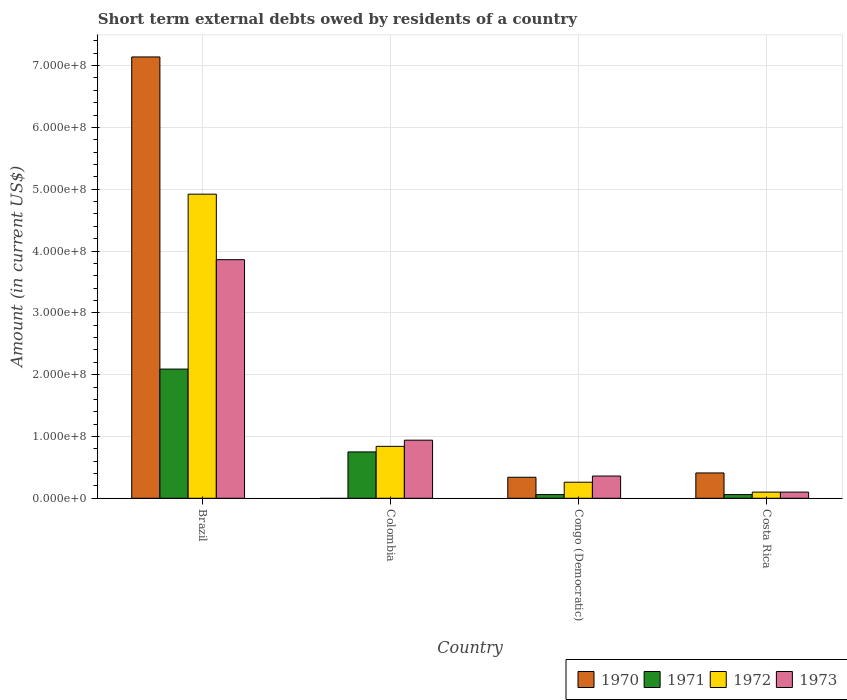Are the number of bars per tick equal to the number of legend labels?
Give a very brief answer. No. How many bars are there on the 1st tick from the right?
Your response must be concise. 4. What is the label of the 4th group of bars from the left?
Give a very brief answer. Costa Rica. In how many cases, is the number of bars for a given country not equal to the number of legend labels?
Keep it short and to the point. 1. What is the amount of short-term external debts owed by residents in 1970 in Brazil?
Make the answer very short. 7.14e+08. Across all countries, what is the maximum amount of short-term external debts owed by residents in 1973?
Offer a terse response. 3.86e+08. What is the total amount of short-term external debts owed by residents in 1973 in the graph?
Provide a short and direct response. 5.26e+08. What is the difference between the amount of short-term external debts owed by residents in 1972 in Brazil and that in Costa Rica?
Keep it short and to the point. 4.82e+08. What is the difference between the amount of short-term external debts owed by residents in 1972 in Colombia and the amount of short-term external debts owed by residents in 1971 in Costa Rica?
Your answer should be very brief. 7.80e+07. What is the average amount of short-term external debts owed by residents in 1971 per country?
Your response must be concise. 7.40e+07. What is the difference between the amount of short-term external debts owed by residents of/in 1971 and amount of short-term external debts owed by residents of/in 1970 in Congo (Democratic)?
Give a very brief answer. -2.80e+07. What is the ratio of the amount of short-term external debts owed by residents in 1973 in Colombia to that in Costa Rica?
Offer a terse response. 9.4. Is the amount of short-term external debts owed by residents in 1972 in Brazil less than that in Congo (Democratic)?
Your answer should be very brief. No. What is the difference between the highest and the second highest amount of short-term external debts owed by residents in 1973?
Your answer should be compact. 3.50e+08. What is the difference between the highest and the lowest amount of short-term external debts owed by residents in 1970?
Keep it short and to the point. 7.14e+08. In how many countries, is the amount of short-term external debts owed by residents in 1972 greater than the average amount of short-term external debts owed by residents in 1972 taken over all countries?
Ensure brevity in your answer.  1. Is it the case that in every country, the sum of the amount of short-term external debts owed by residents in 1972 and amount of short-term external debts owed by residents in 1971 is greater than the amount of short-term external debts owed by residents in 1970?
Make the answer very short. No. What is the difference between two consecutive major ticks on the Y-axis?
Your answer should be compact. 1.00e+08. How many legend labels are there?
Your answer should be very brief. 4. What is the title of the graph?
Ensure brevity in your answer.  Short term external debts owed by residents of a country. Does "1986" appear as one of the legend labels in the graph?
Your answer should be very brief. No. What is the label or title of the X-axis?
Offer a very short reply. Country. What is the label or title of the Y-axis?
Your answer should be compact. Amount (in current US$). What is the Amount (in current US$) of 1970 in Brazil?
Offer a very short reply. 7.14e+08. What is the Amount (in current US$) in 1971 in Brazil?
Make the answer very short. 2.09e+08. What is the Amount (in current US$) of 1972 in Brazil?
Make the answer very short. 4.92e+08. What is the Amount (in current US$) in 1973 in Brazil?
Offer a terse response. 3.86e+08. What is the Amount (in current US$) of 1970 in Colombia?
Provide a short and direct response. 0. What is the Amount (in current US$) in 1971 in Colombia?
Make the answer very short. 7.50e+07. What is the Amount (in current US$) of 1972 in Colombia?
Give a very brief answer. 8.40e+07. What is the Amount (in current US$) in 1973 in Colombia?
Ensure brevity in your answer.  9.40e+07. What is the Amount (in current US$) of 1970 in Congo (Democratic)?
Provide a succinct answer. 3.40e+07. What is the Amount (in current US$) in 1971 in Congo (Democratic)?
Your response must be concise. 6.00e+06. What is the Amount (in current US$) in 1972 in Congo (Democratic)?
Make the answer very short. 2.60e+07. What is the Amount (in current US$) of 1973 in Congo (Democratic)?
Offer a very short reply. 3.60e+07. What is the Amount (in current US$) of 1970 in Costa Rica?
Provide a succinct answer. 4.10e+07. Across all countries, what is the maximum Amount (in current US$) of 1970?
Your answer should be very brief. 7.14e+08. Across all countries, what is the maximum Amount (in current US$) of 1971?
Offer a very short reply. 2.09e+08. Across all countries, what is the maximum Amount (in current US$) in 1972?
Your answer should be very brief. 4.92e+08. Across all countries, what is the maximum Amount (in current US$) in 1973?
Your answer should be compact. 3.86e+08. Across all countries, what is the minimum Amount (in current US$) in 1970?
Offer a very short reply. 0. Across all countries, what is the minimum Amount (in current US$) of 1972?
Provide a succinct answer. 1.00e+07. Across all countries, what is the minimum Amount (in current US$) in 1973?
Your answer should be compact. 1.00e+07. What is the total Amount (in current US$) in 1970 in the graph?
Provide a short and direct response. 7.89e+08. What is the total Amount (in current US$) of 1971 in the graph?
Make the answer very short. 2.96e+08. What is the total Amount (in current US$) in 1972 in the graph?
Make the answer very short. 6.12e+08. What is the total Amount (in current US$) in 1973 in the graph?
Your answer should be compact. 5.26e+08. What is the difference between the Amount (in current US$) in 1971 in Brazil and that in Colombia?
Ensure brevity in your answer.  1.34e+08. What is the difference between the Amount (in current US$) of 1972 in Brazil and that in Colombia?
Ensure brevity in your answer.  4.08e+08. What is the difference between the Amount (in current US$) of 1973 in Brazil and that in Colombia?
Your response must be concise. 2.92e+08. What is the difference between the Amount (in current US$) in 1970 in Brazil and that in Congo (Democratic)?
Make the answer very short. 6.80e+08. What is the difference between the Amount (in current US$) in 1971 in Brazil and that in Congo (Democratic)?
Give a very brief answer. 2.03e+08. What is the difference between the Amount (in current US$) of 1972 in Brazil and that in Congo (Democratic)?
Keep it short and to the point. 4.66e+08. What is the difference between the Amount (in current US$) of 1973 in Brazil and that in Congo (Democratic)?
Provide a succinct answer. 3.50e+08. What is the difference between the Amount (in current US$) of 1970 in Brazil and that in Costa Rica?
Keep it short and to the point. 6.73e+08. What is the difference between the Amount (in current US$) in 1971 in Brazil and that in Costa Rica?
Your response must be concise. 2.03e+08. What is the difference between the Amount (in current US$) of 1972 in Brazil and that in Costa Rica?
Keep it short and to the point. 4.82e+08. What is the difference between the Amount (in current US$) of 1973 in Brazil and that in Costa Rica?
Your answer should be very brief. 3.76e+08. What is the difference between the Amount (in current US$) in 1971 in Colombia and that in Congo (Democratic)?
Make the answer very short. 6.90e+07. What is the difference between the Amount (in current US$) of 1972 in Colombia and that in Congo (Democratic)?
Ensure brevity in your answer.  5.80e+07. What is the difference between the Amount (in current US$) in 1973 in Colombia and that in Congo (Democratic)?
Keep it short and to the point. 5.80e+07. What is the difference between the Amount (in current US$) of 1971 in Colombia and that in Costa Rica?
Provide a short and direct response. 6.90e+07. What is the difference between the Amount (in current US$) of 1972 in Colombia and that in Costa Rica?
Ensure brevity in your answer.  7.40e+07. What is the difference between the Amount (in current US$) in 1973 in Colombia and that in Costa Rica?
Keep it short and to the point. 8.40e+07. What is the difference between the Amount (in current US$) in 1970 in Congo (Democratic) and that in Costa Rica?
Your answer should be very brief. -7.00e+06. What is the difference between the Amount (in current US$) in 1971 in Congo (Democratic) and that in Costa Rica?
Your answer should be very brief. 0. What is the difference between the Amount (in current US$) of 1972 in Congo (Democratic) and that in Costa Rica?
Provide a succinct answer. 1.60e+07. What is the difference between the Amount (in current US$) of 1973 in Congo (Democratic) and that in Costa Rica?
Your answer should be very brief. 2.60e+07. What is the difference between the Amount (in current US$) in 1970 in Brazil and the Amount (in current US$) in 1971 in Colombia?
Your response must be concise. 6.39e+08. What is the difference between the Amount (in current US$) of 1970 in Brazil and the Amount (in current US$) of 1972 in Colombia?
Your answer should be compact. 6.30e+08. What is the difference between the Amount (in current US$) of 1970 in Brazil and the Amount (in current US$) of 1973 in Colombia?
Provide a succinct answer. 6.20e+08. What is the difference between the Amount (in current US$) of 1971 in Brazil and the Amount (in current US$) of 1972 in Colombia?
Give a very brief answer. 1.25e+08. What is the difference between the Amount (in current US$) in 1971 in Brazil and the Amount (in current US$) in 1973 in Colombia?
Your answer should be compact. 1.15e+08. What is the difference between the Amount (in current US$) of 1972 in Brazil and the Amount (in current US$) of 1973 in Colombia?
Give a very brief answer. 3.98e+08. What is the difference between the Amount (in current US$) of 1970 in Brazil and the Amount (in current US$) of 1971 in Congo (Democratic)?
Your answer should be very brief. 7.08e+08. What is the difference between the Amount (in current US$) of 1970 in Brazil and the Amount (in current US$) of 1972 in Congo (Democratic)?
Your answer should be very brief. 6.88e+08. What is the difference between the Amount (in current US$) in 1970 in Brazil and the Amount (in current US$) in 1973 in Congo (Democratic)?
Offer a terse response. 6.78e+08. What is the difference between the Amount (in current US$) in 1971 in Brazil and the Amount (in current US$) in 1972 in Congo (Democratic)?
Give a very brief answer. 1.83e+08. What is the difference between the Amount (in current US$) of 1971 in Brazil and the Amount (in current US$) of 1973 in Congo (Democratic)?
Your answer should be compact. 1.73e+08. What is the difference between the Amount (in current US$) of 1972 in Brazil and the Amount (in current US$) of 1973 in Congo (Democratic)?
Make the answer very short. 4.56e+08. What is the difference between the Amount (in current US$) of 1970 in Brazil and the Amount (in current US$) of 1971 in Costa Rica?
Give a very brief answer. 7.08e+08. What is the difference between the Amount (in current US$) of 1970 in Brazil and the Amount (in current US$) of 1972 in Costa Rica?
Offer a very short reply. 7.04e+08. What is the difference between the Amount (in current US$) in 1970 in Brazil and the Amount (in current US$) in 1973 in Costa Rica?
Ensure brevity in your answer.  7.04e+08. What is the difference between the Amount (in current US$) of 1971 in Brazil and the Amount (in current US$) of 1972 in Costa Rica?
Ensure brevity in your answer.  1.99e+08. What is the difference between the Amount (in current US$) in 1971 in Brazil and the Amount (in current US$) in 1973 in Costa Rica?
Keep it short and to the point. 1.99e+08. What is the difference between the Amount (in current US$) of 1972 in Brazil and the Amount (in current US$) of 1973 in Costa Rica?
Give a very brief answer. 4.82e+08. What is the difference between the Amount (in current US$) in 1971 in Colombia and the Amount (in current US$) in 1972 in Congo (Democratic)?
Make the answer very short. 4.90e+07. What is the difference between the Amount (in current US$) in 1971 in Colombia and the Amount (in current US$) in 1973 in Congo (Democratic)?
Offer a very short reply. 3.90e+07. What is the difference between the Amount (in current US$) in 1972 in Colombia and the Amount (in current US$) in 1973 in Congo (Democratic)?
Provide a succinct answer. 4.80e+07. What is the difference between the Amount (in current US$) of 1971 in Colombia and the Amount (in current US$) of 1972 in Costa Rica?
Make the answer very short. 6.50e+07. What is the difference between the Amount (in current US$) in 1971 in Colombia and the Amount (in current US$) in 1973 in Costa Rica?
Offer a terse response. 6.50e+07. What is the difference between the Amount (in current US$) in 1972 in Colombia and the Amount (in current US$) in 1973 in Costa Rica?
Make the answer very short. 7.40e+07. What is the difference between the Amount (in current US$) of 1970 in Congo (Democratic) and the Amount (in current US$) of 1971 in Costa Rica?
Your answer should be compact. 2.80e+07. What is the difference between the Amount (in current US$) of 1970 in Congo (Democratic) and the Amount (in current US$) of 1972 in Costa Rica?
Provide a succinct answer. 2.40e+07. What is the difference between the Amount (in current US$) of 1970 in Congo (Democratic) and the Amount (in current US$) of 1973 in Costa Rica?
Give a very brief answer. 2.40e+07. What is the difference between the Amount (in current US$) in 1972 in Congo (Democratic) and the Amount (in current US$) in 1973 in Costa Rica?
Offer a very short reply. 1.60e+07. What is the average Amount (in current US$) in 1970 per country?
Offer a very short reply. 1.97e+08. What is the average Amount (in current US$) of 1971 per country?
Provide a short and direct response. 7.40e+07. What is the average Amount (in current US$) in 1972 per country?
Ensure brevity in your answer.  1.53e+08. What is the average Amount (in current US$) of 1973 per country?
Keep it short and to the point. 1.32e+08. What is the difference between the Amount (in current US$) of 1970 and Amount (in current US$) of 1971 in Brazil?
Give a very brief answer. 5.05e+08. What is the difference between the Amount (in current US$) in 1970 and Amount (in current US$) in 1972 in Brazil?
Your answer should be very brief. 2.22e+08. What is the difference between the Amount (in current US$) in 1970 and Amount (in current US$) in 1973 in Brazil?
Offer a terse response. 3.28e+08. What is the difference between the Amount (in current US$) in 1971 and Amount (in current US$) in 1972 in Brazil?
Your response must be concise. -2.83e+08. What is the difference between the Amount (in current US$) of 1971 and Amount (in current US$) of 1973 in Brazil?
Offer a very short reply. -1.77e+08. What is the difference between the Amount (in current US$) of 1972 and Amount (in current US$) of 1973 in Brazil?
Keep it short and to the point. 1.06e+08. What is the difference between the Amount (in current US$) in 1971 and Amount (in current US$) in 1972 in Colombia?
Offer a terse response. -9.00e+06. What is the difference between the Amount (in current US$) in 1971 and Amount (in current US$) in 1973 in Colombia?
Ensure brevity in your answer.  -1.90e+07. What is the difference between the Amount (in current US$) of 1972 and Amount (in current US$) of 1973 in Colombia?
Give a very brief answer. -1.00e+07. What is the difference between the Amount (in current US$) in 1970 and Amount (in current US$) in 1971 in Congo (Democratic)?
Offer a very short reply. 2.80e+07. What is the difference between the Amount (in current US$) of 1970 and Amount (in current US$) of 1972 in Congo (Democratic)?
Your answer should be very brief. 8.00e+06. What is the difference between the Amount (in current US$) in 1970 and Amount (in current US$) in 1973 in Congo (Democratic)?
Offer a very short reply. -2.00e+06. What is the difference between the Amount (in current US$) in 1971 and Amount (in current US$) in 1972 in Congo (Democratic)?
Offer a very short reply. -2.00e+07. What is the difference between the Amount (in current US$) in 1971 and Amount (in current US$) in 1973 in Congo (Democratic)?
Provide a succinct answer. -3.00e+07. What is the difference between the Amount (in current US$) in 1972 and Amount (in current US$) in 1973 in Congo (Democratic)?
Your response must be concise. -1.00e+07. What is the difference between the Amount (in current US$) of 1970 and Amount (in current US$) of 1971 in Costa Rica?
Make the answer very short. 3.50e+07. What is the difference between the Amount (in current US$) of 1970 and Amount (in current US$) of 1972 in Costa Rica?
Your response must be concise. 3.10e+07. What is the difference between the Amount (in current US$) of 1970 and Amount (in current US$) of 1973 in Costa Rica?
Offer a terse response. 3.10e+07. What is the difference between the Amount (in current US$) in 1972 and Amount (in current US$) in 1973 in Costa Rica?
Ensure brevity in your answer.  0. What is the ratio of the Amount (in current US$) of 1971 in Brazil to that in Colombia?
Your answer should be compact. 2.79. What is the ratio of the Amount (in current US$) in 1972 in Brazil to that in Colombia?
Offer a terse response. 5.86. What is the ratio of the Amount (in current US$) in 1973 in Brazil to that in Colombia?
Provide a short and direct response. 4.11. What is the ratio of the Amount (in current US$) of 1970 in Brazil to that in Congo (Democratic)?
Make the answer very short. 21. What is the ratio of the Amount (in current US$) of 1971 in Brazil to that in Congo (Democratic)?
Your response must be concise. 34.83. What is the ratio of the Amount (in current US$) in 1972 in Brazil to that in Congo (Democratic)?
Keep it short and to the point. 18.92. What is the ratio of the Amount (in current US$) of 1973 in Brazil to that in Congo (Democratic)?
Your response must be concise. 10.72. What is the ratio of the Amount (in current US$) in 1970 in Brazil to that in Costa Rica?
Keep it short and to the point. 17.41. What is the ratio of the Amount (in current US$) in 1971 in Brazil to that in Costa Rica?
Give a very brief answer. 34.83. What is the ratio of the Amount (in current US$) in 1972 in Brazil to that in Costa Rica?
Your answer should be very brief. 49.2. What is the ratio of the Amount (in current US$) of 1973 in Brazil to that in Costa Rica?
Your answer should be compact. 38.6. What is the ratio of the Amount (in current US$) of 1972 in Colombia to that in Congo (Democratic)?
Your answer should be very brief. 3.23. What is the ratio of the Amount (in current US$) of 1973 in Colombia to that in Congo (Democratic)?
Your answer should be compact. 2.61. What is the ratio of the Amount (in current US$) in 1971 in Colombia to that in Costa Rica?
Ensure brevity in your answer.  12.5. What is the ratio of the Amount (in current US$) of 1972 in Colombia to that in Costa Rica?
Offer a terse response. 8.4. What is the ratio of the Amount (in current US$) of 1970 in Congo (Democratic) to that in Costa Rica?
Offer a very short reply. 0.83. What is the ratio of the Amount (in current US$) of 1973 in Congo (Democratic) to that in Costa Rica?
Your response must be concise. 3.6. What is the difference between the highest and the second highest Amount (in current US$) in 1970?
Your response must be concise. 6.73e+08. What is the difference between the highest and the second highest Amount (in current US$) in 1971?
Give a very brief answer. 1.34e+08. What is the difference between the highest and the second highest Amount (in current US$) in 1972?
Offer a terse response. 4.08e+08. What is the difference between the highest and the second highest Amount (in current US$) of 1973?
Ensure brevity in your answer.  2.92e+08. What is the difference between the highest and the lowest Amount (in current US$) in 1970?
Provide a short and direct response. 7.14e+08. What is the difference between the highest and the lowest Amount (in current US$) in 1971?
Give a very brief answer. 2.03e+08. What is the difference between the highest and the lowest Amount (in current US$) of 1972?
Provide a short and direct response. 4.82e+08. What is the difference between the highest and the lowest Amount (in current US$) in 1973?
Provide a short and direct response. 3.76e+08. 